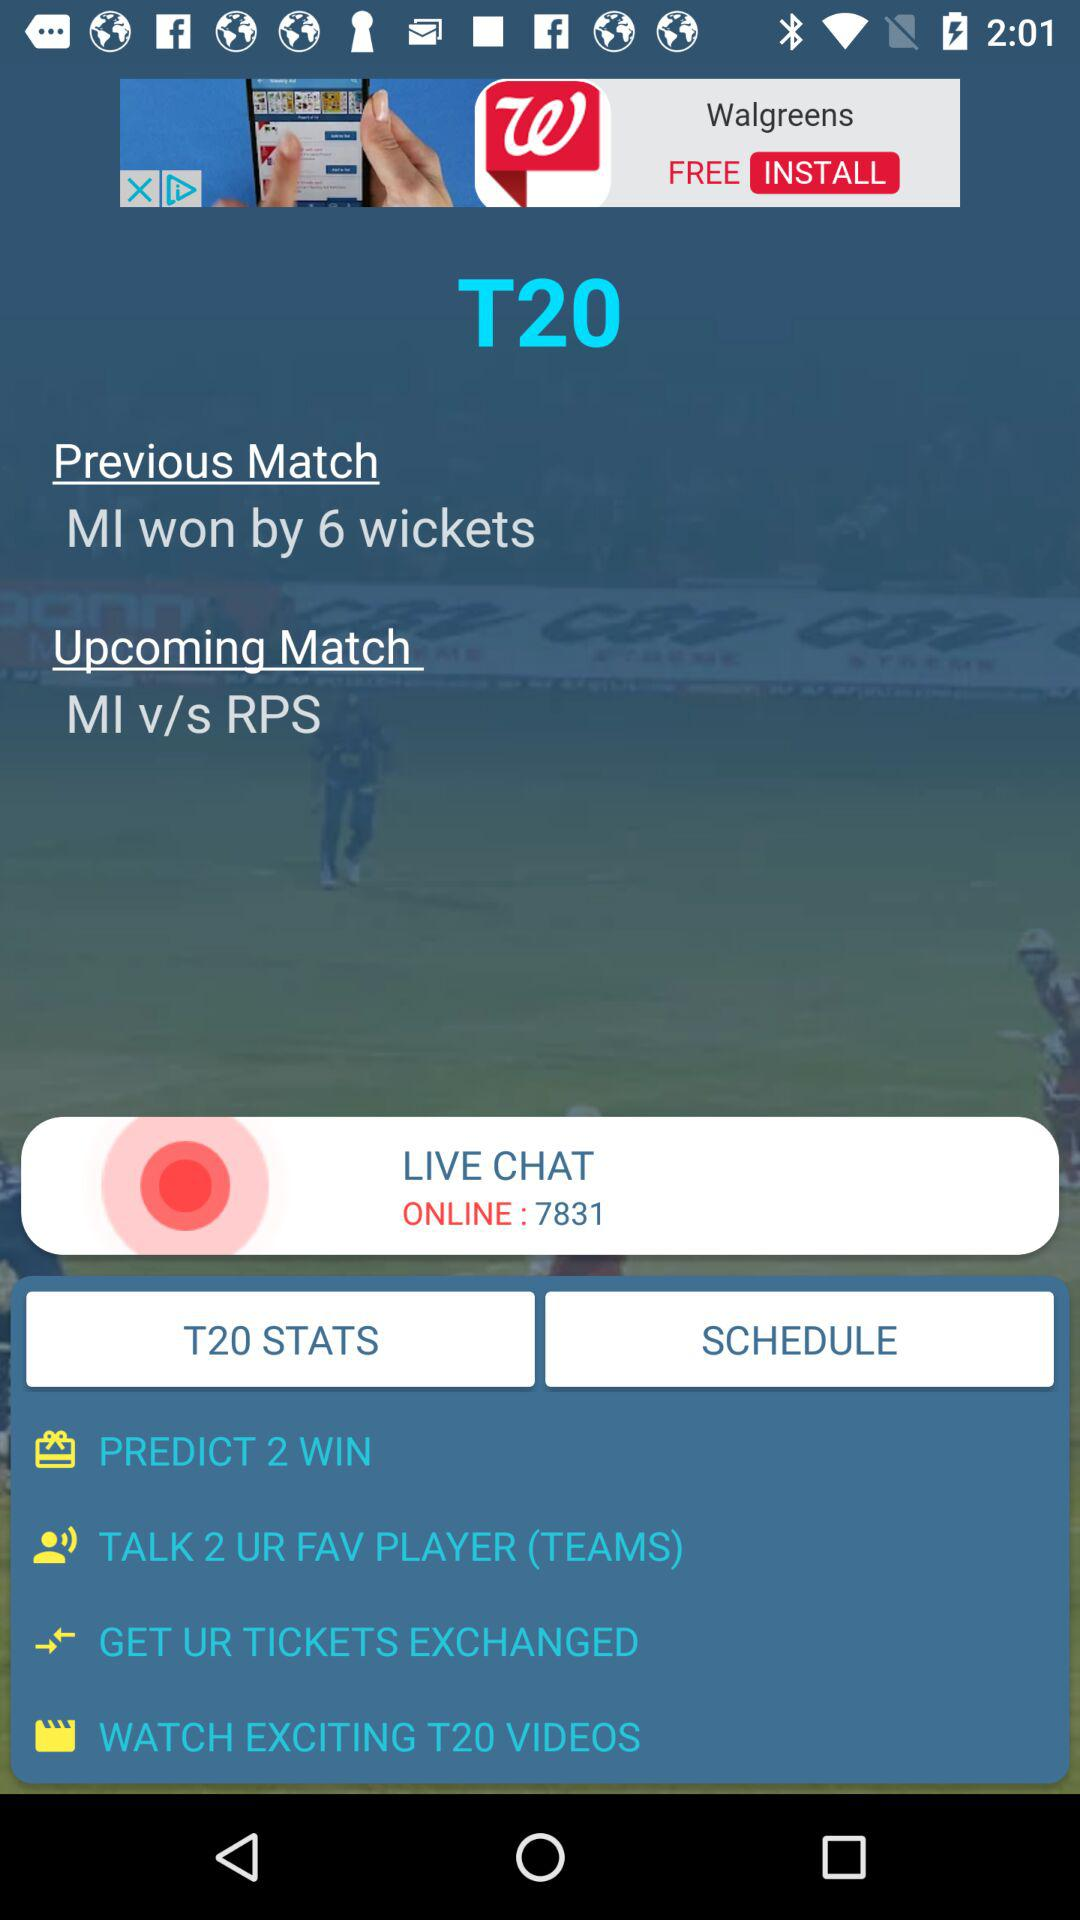By how many wickets MI won? MI won by 6 wickets. 